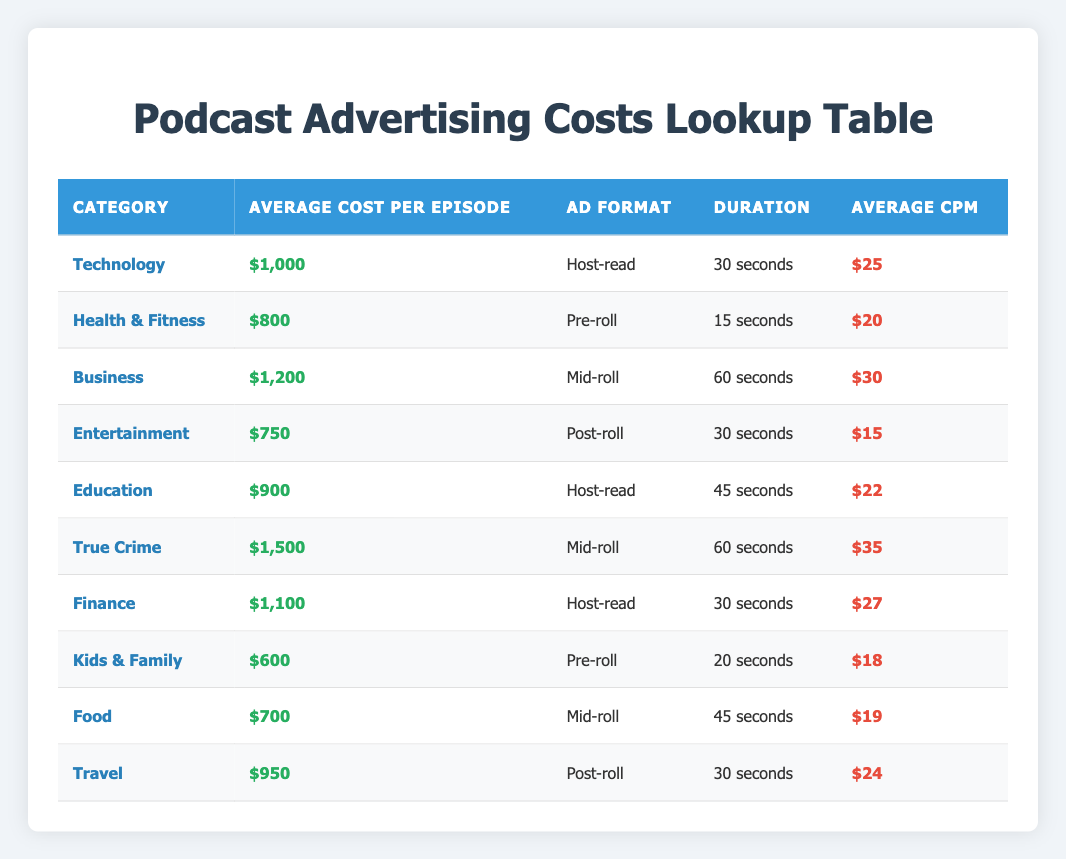What is the average advertising cost per episode for the "True Crime" category? The table shows that the average cost per episode for the "True Crime" category is listed directly. It specifies $1,500.
Answer: $1,500 Which ad format has the highest average CPM among the podcast categories? By examining the "Average CPM" column, the highest value is $35, associated with the "Mid-roll" ad format in the "True Crime" category.
Answer: Mid-roll What is the average cost per episode for all podcast categories? To calculate the average, sum all average costs: (1000 + 800 + 1200 + 750 + 900 + 1500 + 1100 + 600 + 700 + 950) = 8650. Divide by the number of categories (10), which gives 8650/10 = 865.
Answer: $865 Is the average cost per episode for "Kids & Family" lower than the cost for "Food"? The average cost for "Kids & Family" is $600, while "Food" is $700. Since $600 is less than $700, the statement is true.
Answer: Yes Which categories have a host-read ad format and what is their average cost? The table lists two categories with a host-read format: "Technology" at $1,000 and "Finance" at $1,100.
Answer: Technology - $1,000, Finance - $1,100 What is the total average CPM for all podcast categories listed? To find the total average CPM, add all the CPM values: (25 + 20 + 30 + 15 + 22 + 35 + 27 + 18 + 19 + 24) =  25 + 20 + 30 + 15 + 22 + 35 + 27 + 18 + 19 + 24 =  20 + 30 + 15 + 22 + 35 + 27 + 18 + 19 + 24 = 20 + 30 = 50 + 15 = 65 + 22 = 87 + 35 = 122 + 27 = 149 + 18 = 167 + 19 = 186 + 24 = 210 =  210. Then divide this by the number of categories (10), resulting in 210/10 = 21.
Answer: $21 Is there a category where the average cost per episode is $750 or less? Yes, the "Entertainment" category has an average cost of $750, making the statement true.
Answer: Yes Which category has the highest average cost per episode and what is that cost? The table indicates that the "True Crime" category has the highest average cost at $1,500.
Answer: True Crime - $1,500 